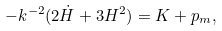Convert formula to latex. <formula><loc_0><loc_0><loc_500><loc_500>- k ^ { - 2 } ( 2 \dot { H } + 3 H ^ { 2 } ) = K + p _ { m } ,</formula> 